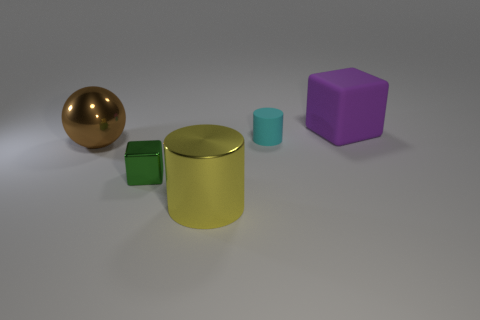Do the metal cylinder and the matte thing that is to the right of the small cylinder have the same color?
Your response must be concise. No. What is the material of the brown object?
Make the answer very short. Metal. What is the color of the thing that is right of the cyan rubber cylinder?
Provide a succinct answer. Purple. What number of big objects have the same color as the small cube?
Your response must be concise. 0. What number of big shiny things are behind the tiny metallic block and right of the big brown metal ball?
Ensure brevity in your answer.  0. There is a thing that is the same size as the metallic cube; what shape is it?
Provide a short and direct response. Cylinder. What is the size of the green shiny object?
Provide a succinct answer. Small. There is a small object on the right side of the block in front of the large object behind the small cyan object; what is its material?
Your answer should be very brief. Rubber. What color is the large cylinder that is made of the same material as the green cube?
Offer a terse response. Yellow. There is a cube on the right side of the small thing that is behind the brown shiny ball; what number of cubes are in front of it?
Your answer should be compact. 1. 